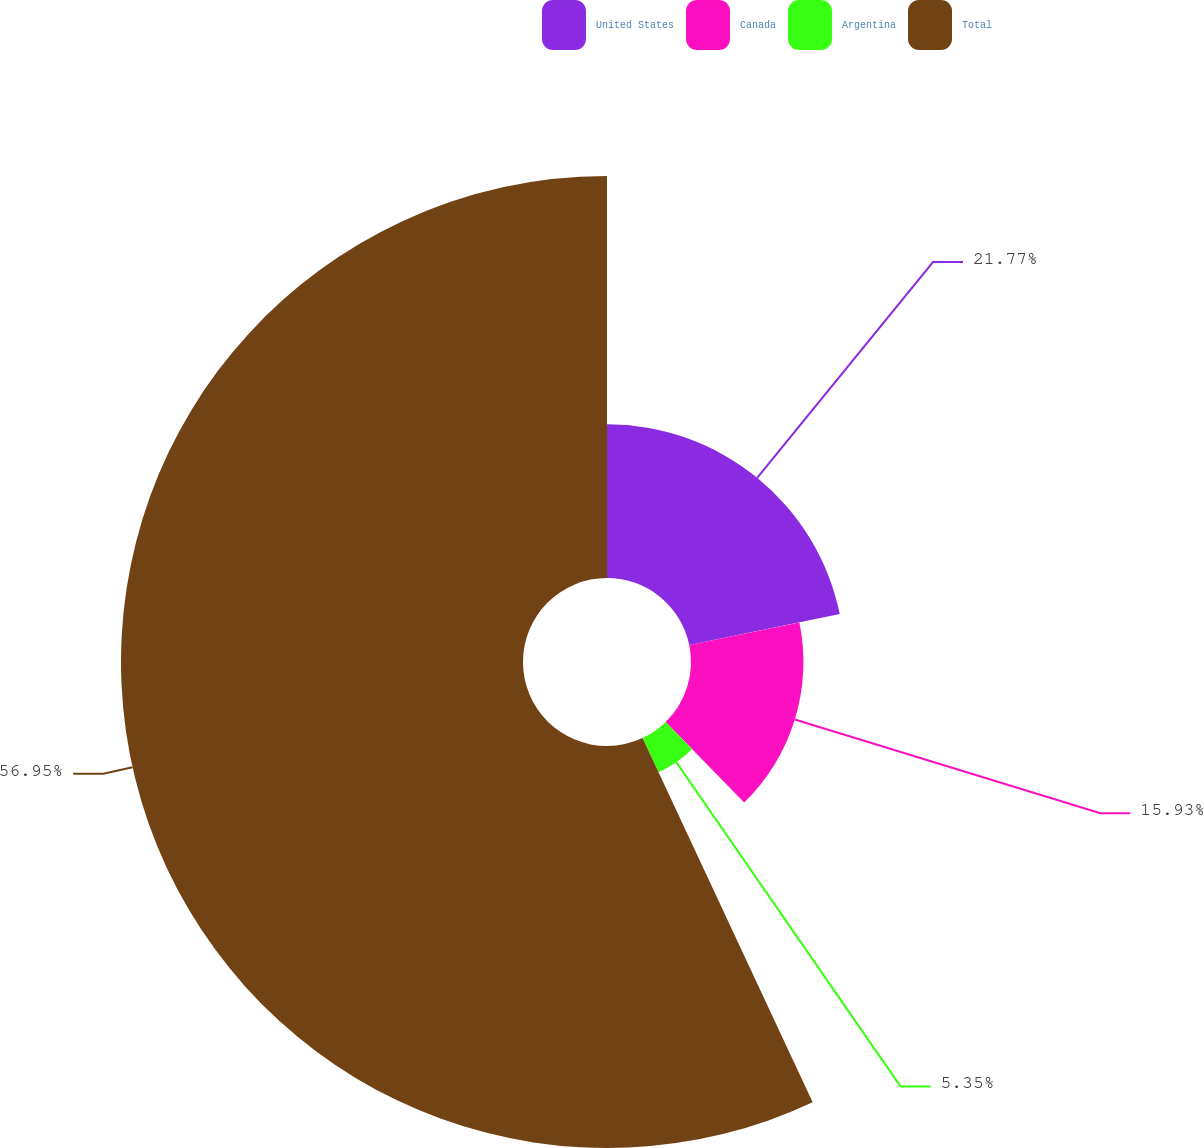Convert chart to OTSL. <chart><loc_0><loc_0><loc_500><loc_500><pie_chart><fcel>United States<fcel>Canada<fcel>Argentina<fcel>Total<nl><fcel>21.77%<fcel>15.93%<fcel>5.35%<fcel>56.96%<nl></chart> 